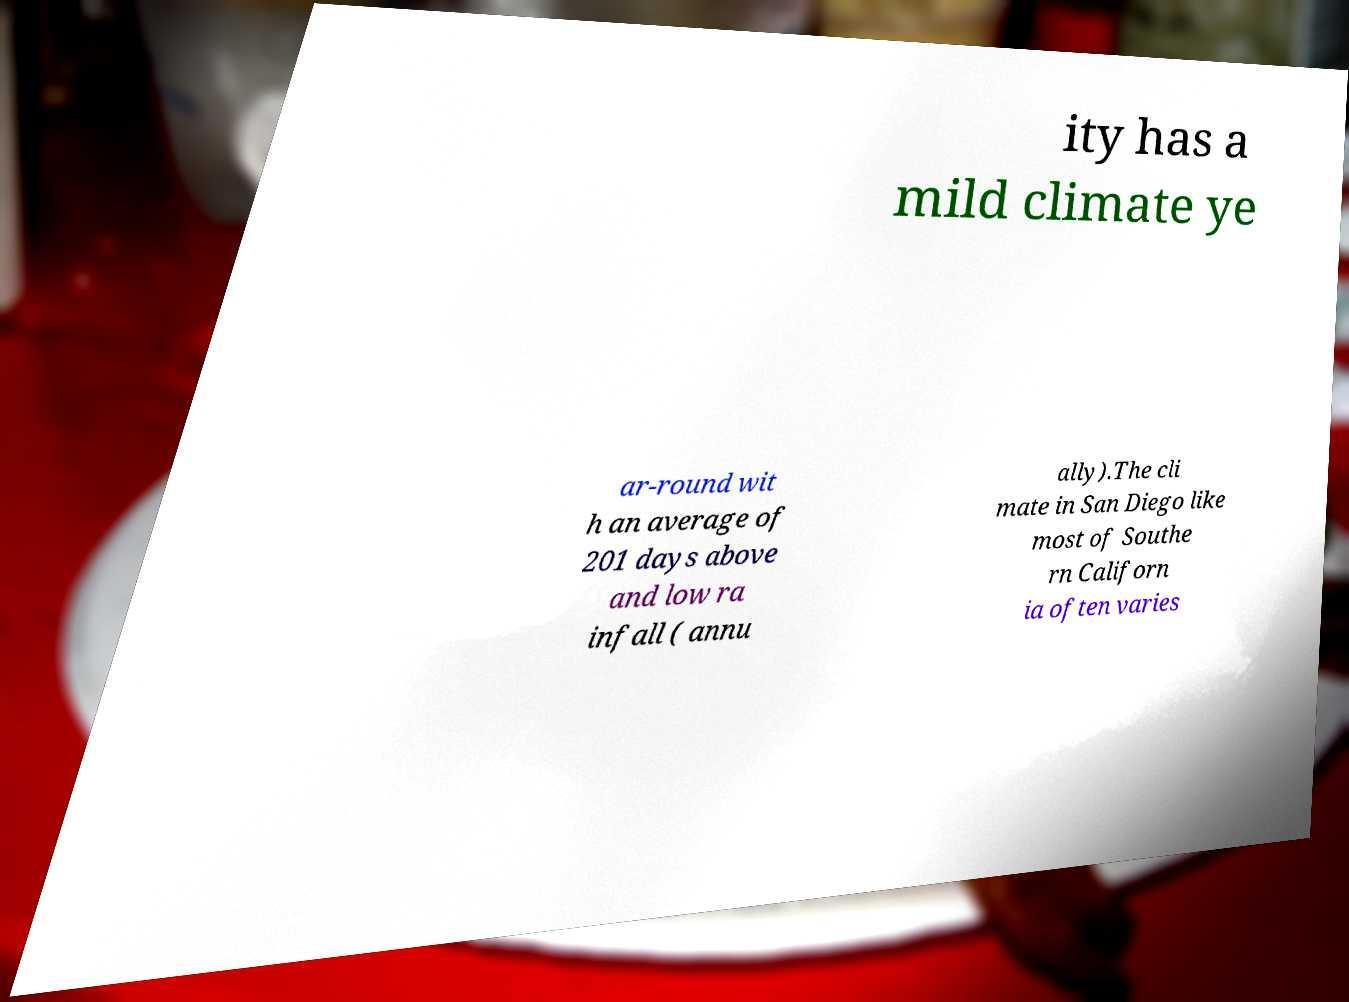Could you assist in decoding the text presented in this image and type it out clearly? ity has a mild climate ye ar-round wit h an average of 201 days above and low ra infall ( annu ally).The cli mate in San Diego like most of Southe rn Californ ia often varies 